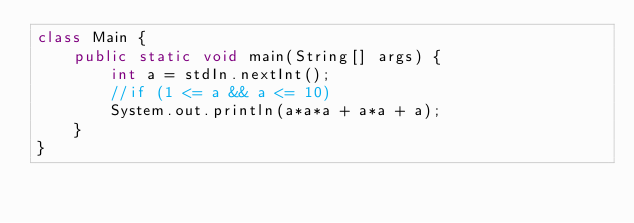<code> <loc_0><loc_0><loc_500><loc_500><_Java_>class Main {
    public static void main(String[] args) {
        int a = stdIn.nextInt();
        //if (1 <= a && a <= 10)
        System.out.println(a*a*a + a*a + a);
    }
}</code> 